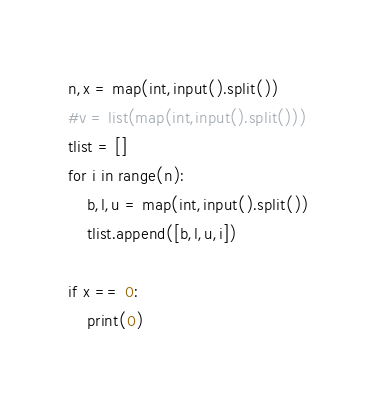<code> <loc_0><loc_0><loc_500><loc_500><_Python_>n,x = map(int,input().split())
#v = list(map(int,input().split()))
tlist = []
for i in range(n):
    b,l,u = map(int,input().split())
    tlist.append([b,l,u,i])

if x == 0:
  	print(0)</code> 